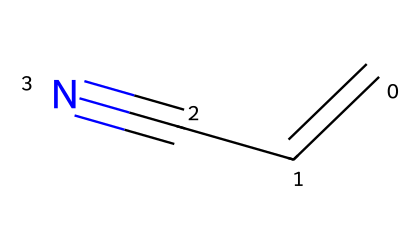What is the molecular formula of acrylonitrile? The structure contains 3 carbon atoms (C), 3 hydrogen atoms (H), and 1 nitrogen atom (N). Therefore, the molecular formula is obtained by counting the atoms: C3H3N.
Answer: C3H3N How many π bonds are present in acrylonitrile? The structure shows a double bond between the first carbon atom and the second carbon atom (C=C) and a triple bond between the second carbon and the nitrogen (C#N). Each bond type indicates π bonds: 1 for double bond and 2 for triple bond, resulting in a total of 3 π bonds.
Answer: 3 What type of functional group is present in acrylonitrile? The presence of the cyano group (-C≡N) indicates that this compound is classified as a nitrile. The triple bond between carbon and nitrogen is characteristic of nitriles.
Answer: nitrile How many hydrogen atoms are attached to the first carbon in acrylonitrile? The first carbon in acrylonitrile is connected to one hydrogen atom, as indicated by the bonding structure. The first carbon is also engaged in a double bond with the second carbon and has 1 hydrogen.
Answer: 1 What is the hybridization state of the carbon adjacent to the nitrogen in acrylonitrile? The carbon adjacent to nitrogen is involved in a triple bond (C#N) and a single bond with another carbon, making it sp hybridized. In sp hybridization, there are two hybrid orbitals formed for the carbon that is bonded to two different atoms.
Answer: sp What is the primary industrial application of acrylonitrile? Acrylonitrile is mainly used to produce acrylic fibers, which are used in textiles. Additionally, it is a precursor in the production of various plastics for electronic components.
Answer: plastics How does the presence of the nitrile group influence the reactivity of acrylonitrile? The nitrile group is polar due to the electronegativity difference between carbon and nitrogen, making acrylonitrile reactive. This polarity facilitates nucleophilic attack, a characteristic behavior of nitriles.
Answer: reactive 